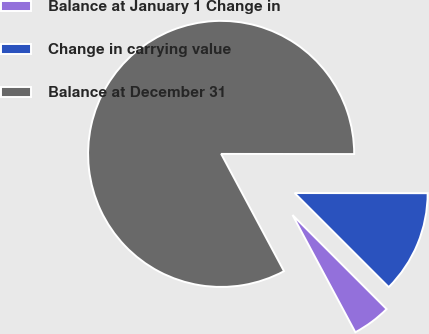Convert chart. <chart><loc_0><loc_0><loc_500><loc_500><pie_chart><fcel>Balance at January 1 Change in<fcel>Change in carrying value<fcel>Balance at December 31<nl><fcel>4.67%<fcel>12.48%<fcel>82.85%<nl></chart> 